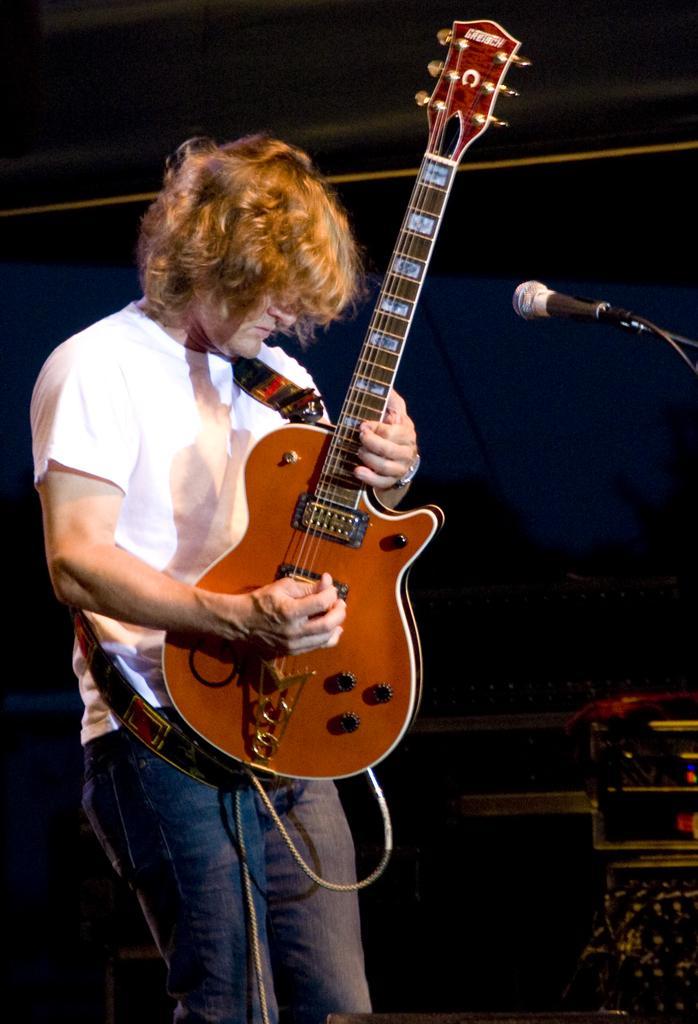How would you summarize this image in a sentence or two? In this image i can see a man is playing a guitar by holding in his hands in front of the microphone. The man is wearing a white color t shirt and a jeans. 